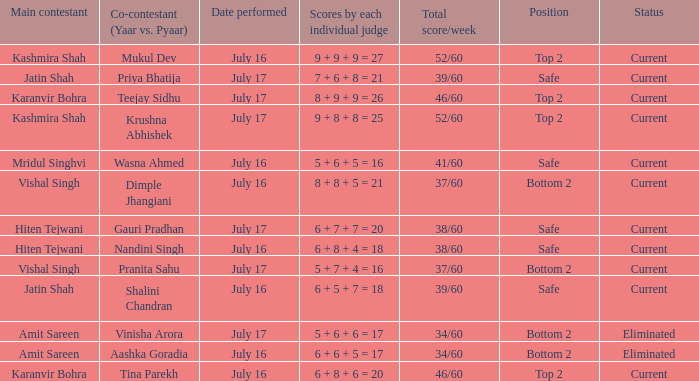What place did pranita sahu's team secure? Bottom 2. 